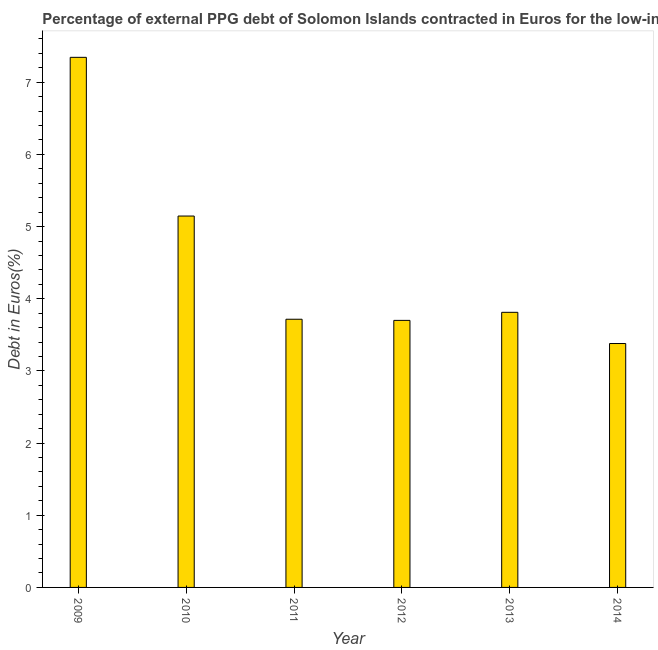What is the title of the graph?
Provide a short and direct response. Percentage of external PPG debt of Solomon Islands contracted in Euros for the low-income countries. What is the label or title of the Y-axis?
Your answer should be compact. Debt in Euros(%). What is the currency composition of ppg debt in 2011?
Your answer should be very brief. 3.72. Across all years, what is the maximum currency composition of ppg debt?
Offer a terse response. 7.34. Across all years, what is the minimum currency composition of ppg debt?
Offer a very short reply. 3.38. What is the sum of the currency composition of ppg debt?
Your answer should be very brief. 27.1. What is the difference between the currency composition of ppg debt in 2010 and 2011?
Your answer should be compact. 1.43. What is the average currency composition of ppg debt per year?
Your response must be concise. 4.52. What is the median currency composition of ppg debt?
Provide a short and direct response. 3.76. In how many years, is the currency composition of ppg debt greater than 1.8 %?
Keep it short and to the point. 6. What is the ratio of the currency composition of ppg debt in 2010 to that in 2012?
Provide a short and direct response. 1.39. What is the difference between the highest and the second highest currency composition of ppg debt?
Your answer should be very brief. 2.2. What is the difference between the highest and the lowest currency composition of ppg debt?
Your response must be concise. 3.97. How many bars are there?
Offer a terse response. 6. How many years are there in the graph?
Your response must be concise. 6. Are the values on the major ticks of Y-axis written in scientific E-notation?
Make the answer very short. No. What is the Debt in Euros(%) of 2009?
Give a very brief answer. 7.34. What is the Debt in Euros(%) in 2010?
Make the answer very short. 5.15. What is the Debt in Euros(%) in 2011?
Offer a very short reply. 3.72. What is the Debt in Euros(%) of 2012?
Give a very brief answer. 3.7. What is the Debt in Euros(%) of 2013?
Offer a very short reply. 3.81. What is the Debt in Euros(%) in 2014?
Provide a short and direct response. 3.38. What is the difference between the Debt in Euros(%) in 2009 and 2010?
Your response must be concise. 2.2. What is the difference between the Debt in Euros(%) in 2009 and 2011?
Provide a succinct answer. 3.63. What is the difference between the Debt in Euros(%) in 2009 and 2012?
Ensure brevity in your answer.  3.64. What is the difference between the Debt in Euros(%) in 2009 and 2013?
Provide a succinct answer. 3.53. What is the difference between the Debt in Euros(%) in 2009 and 2014?
Keep it short and to the point. 3.97. What is the difference between the Debt in Euros(%) in 2010 and 2011?
Make the answer very short. 1.43. What is the difference between the Debt in Euros(%) in 2010 and 2012?
Give a very brief answer. 1.45. What is the difference between the Debt in Euros(%) in 2010 and 2013?
Your answer should be compact. 1.33. What is the difference between the Debt in Euros(%) in 2010 and 2014?
Make the answer very short. 1.77. What is the difference between the Debt in Euros(%) in 2011 and 2012?
Offer a very short reply. 0.02. What is the difference between the Debt in Euros(%) in 2011 and 2013?
Your answer should be very brief. -0.1. What is the difference between the Debt in Euros(%) in 2011 and 2014?
Your answer should be compact. 0.34. What is the difference between the Debt in Euros(%) in 2012 and 2013?
Provide a succinct answer. -0.11. What is the difference between the Debt in Euros(%) in 2012 and 2014?
Your answer should be very brief. 0.32. What is the difference between the Debt in Euros(%) in 2013 and 2014?
Provide a short and direct response. 0.43. What is the ratio of the Debt in Euros(%) in 2009 to that in 2010?
Your response must be concise. 1.43. What is the ratio of the Debt in Euros(%) in 2009 to that in 2011?
Give a very brief answer. 1.98. What is the ratio of the Debt in Euros(%) in 2009 to that in 2012?
Offer a very short reply. 1.99. What is the ratio of the Debt in Euros(%) in 2009 to that in 2013?
Provide a short and direct response. 1.93. What is the ratio of the Debt in Euros(%) in 2009 to that in 2014?
Provide a short and direct response. 2.17. What is the ratio of the Debt in Euros(%) in 2010 to that in 2011?
Your answer should be compact. 1.39. What is the ratio of the Debt in Euros(%) in 2010 to that in 2012?
Your answer should be compact. 1.39. What is the ratio of the Debt in Euros(%) in 2010 to that in 2013?
Offer a very short reply. 1.35. What is the ratio of the Debt in Euros(%) in 2010 to that in 2014?
Your response must be concise. 1.52. What is the ratio of the Debt in Euros(%) in 2012 to that in 2013?
Your answer should be compact. 0.97. What is the ratio of the Debt in Euros(%) in 2012 to that in 2014?
Make the answer very short. 1.09. What is the ratio of the Debt in Euros(%) in 2013 to that in 2014?
Your answer should be compact. 1.13. 